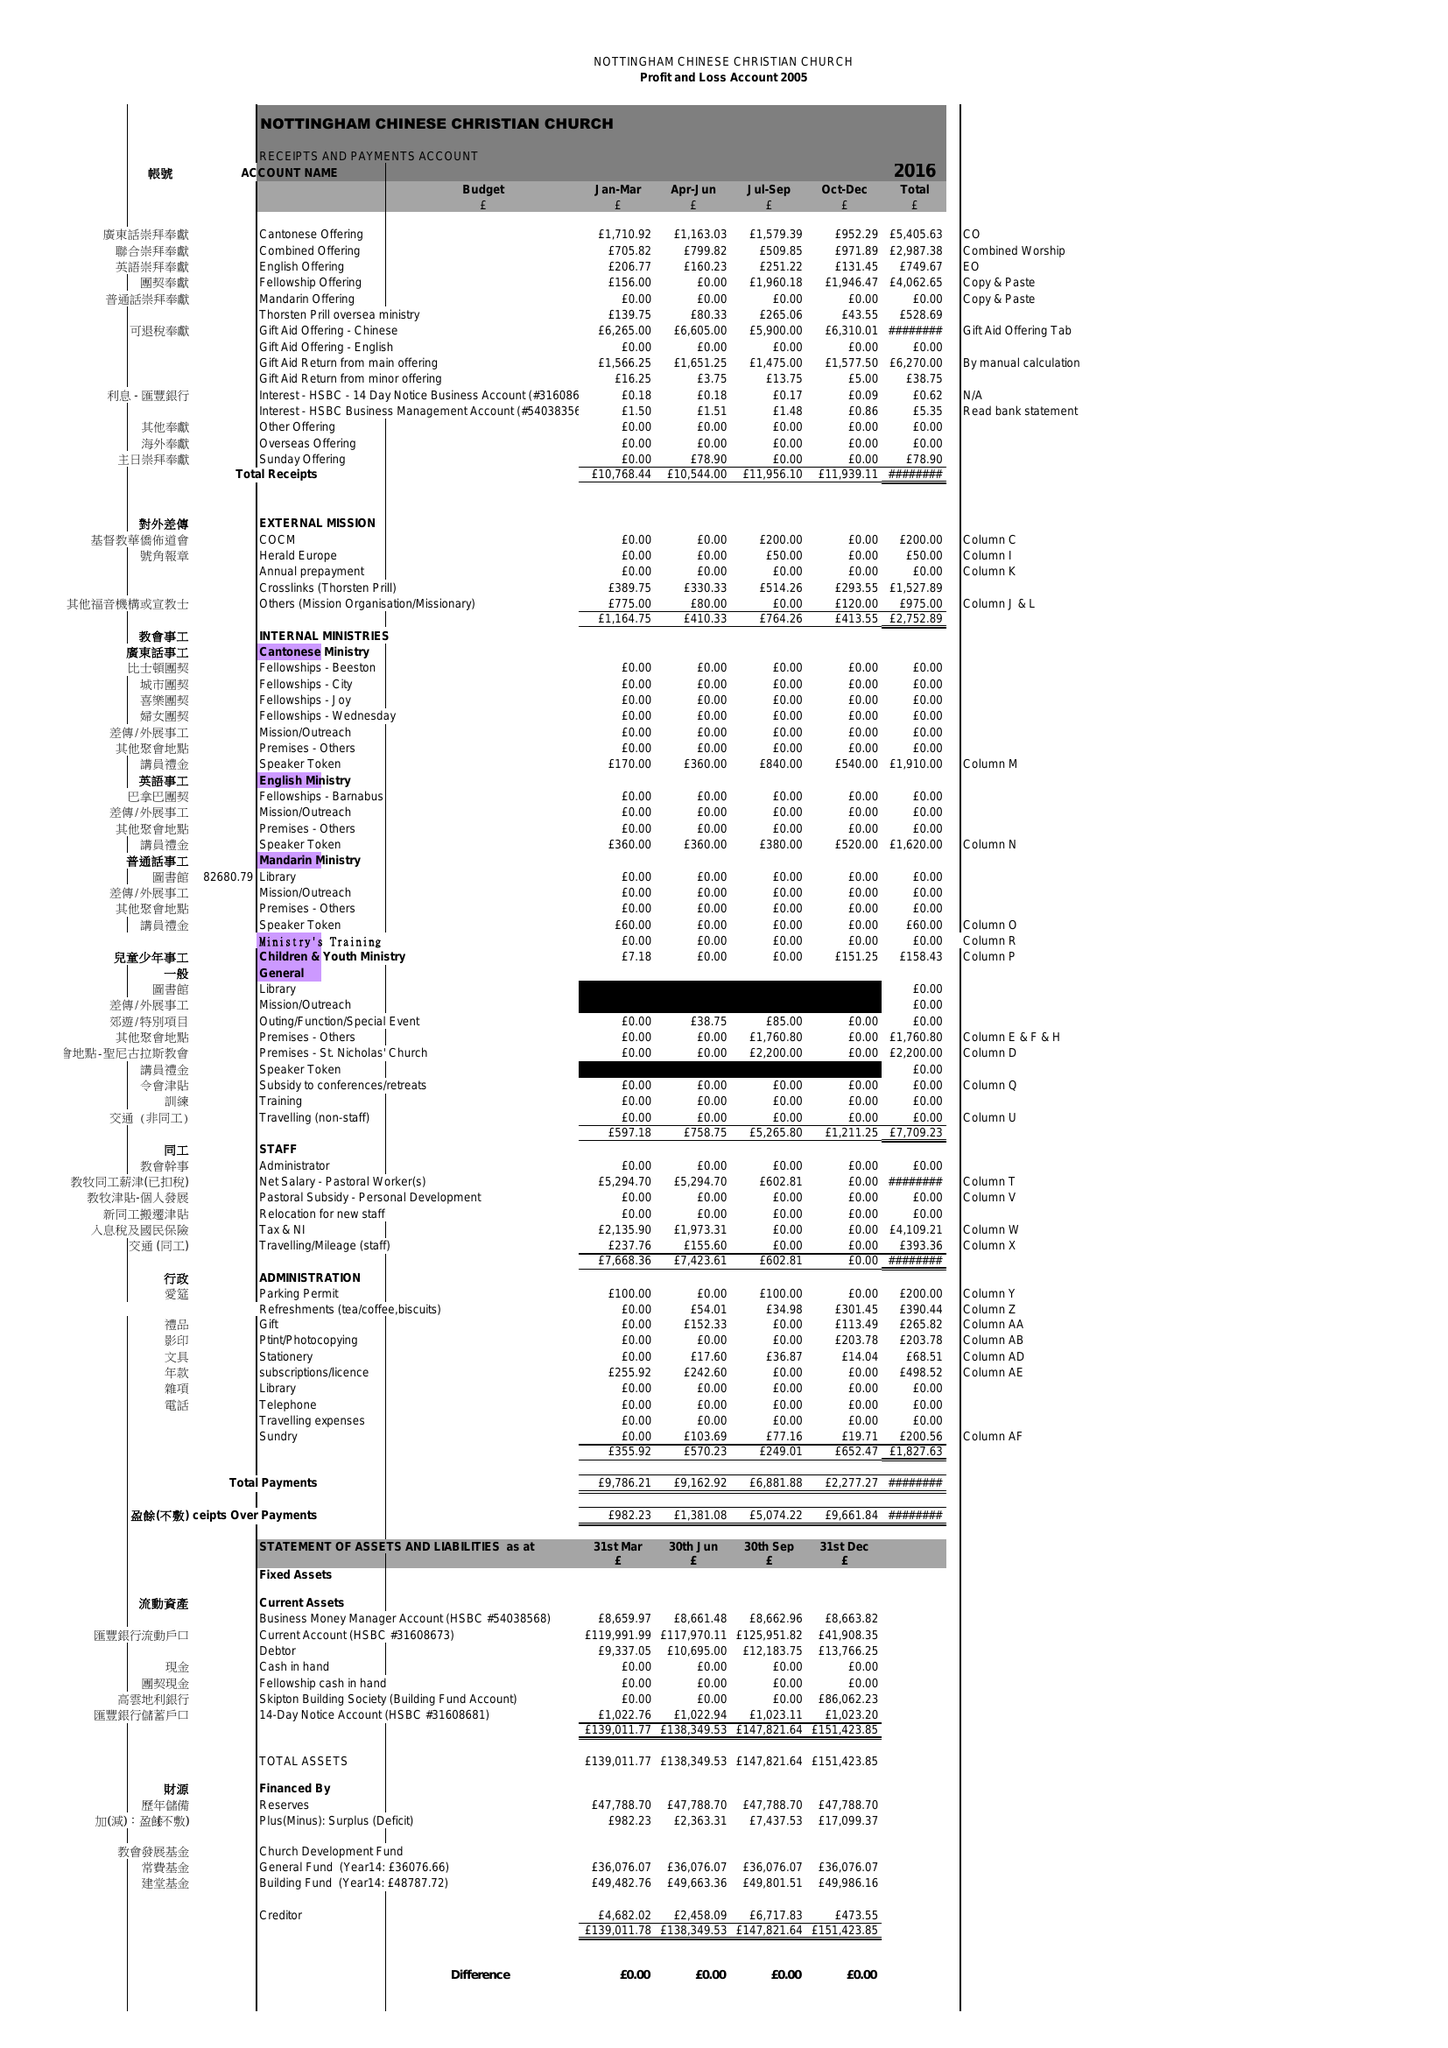What is the value for the income_annually_in_british_pounds?
Answer the question using a single word or phrase. 45208.00 